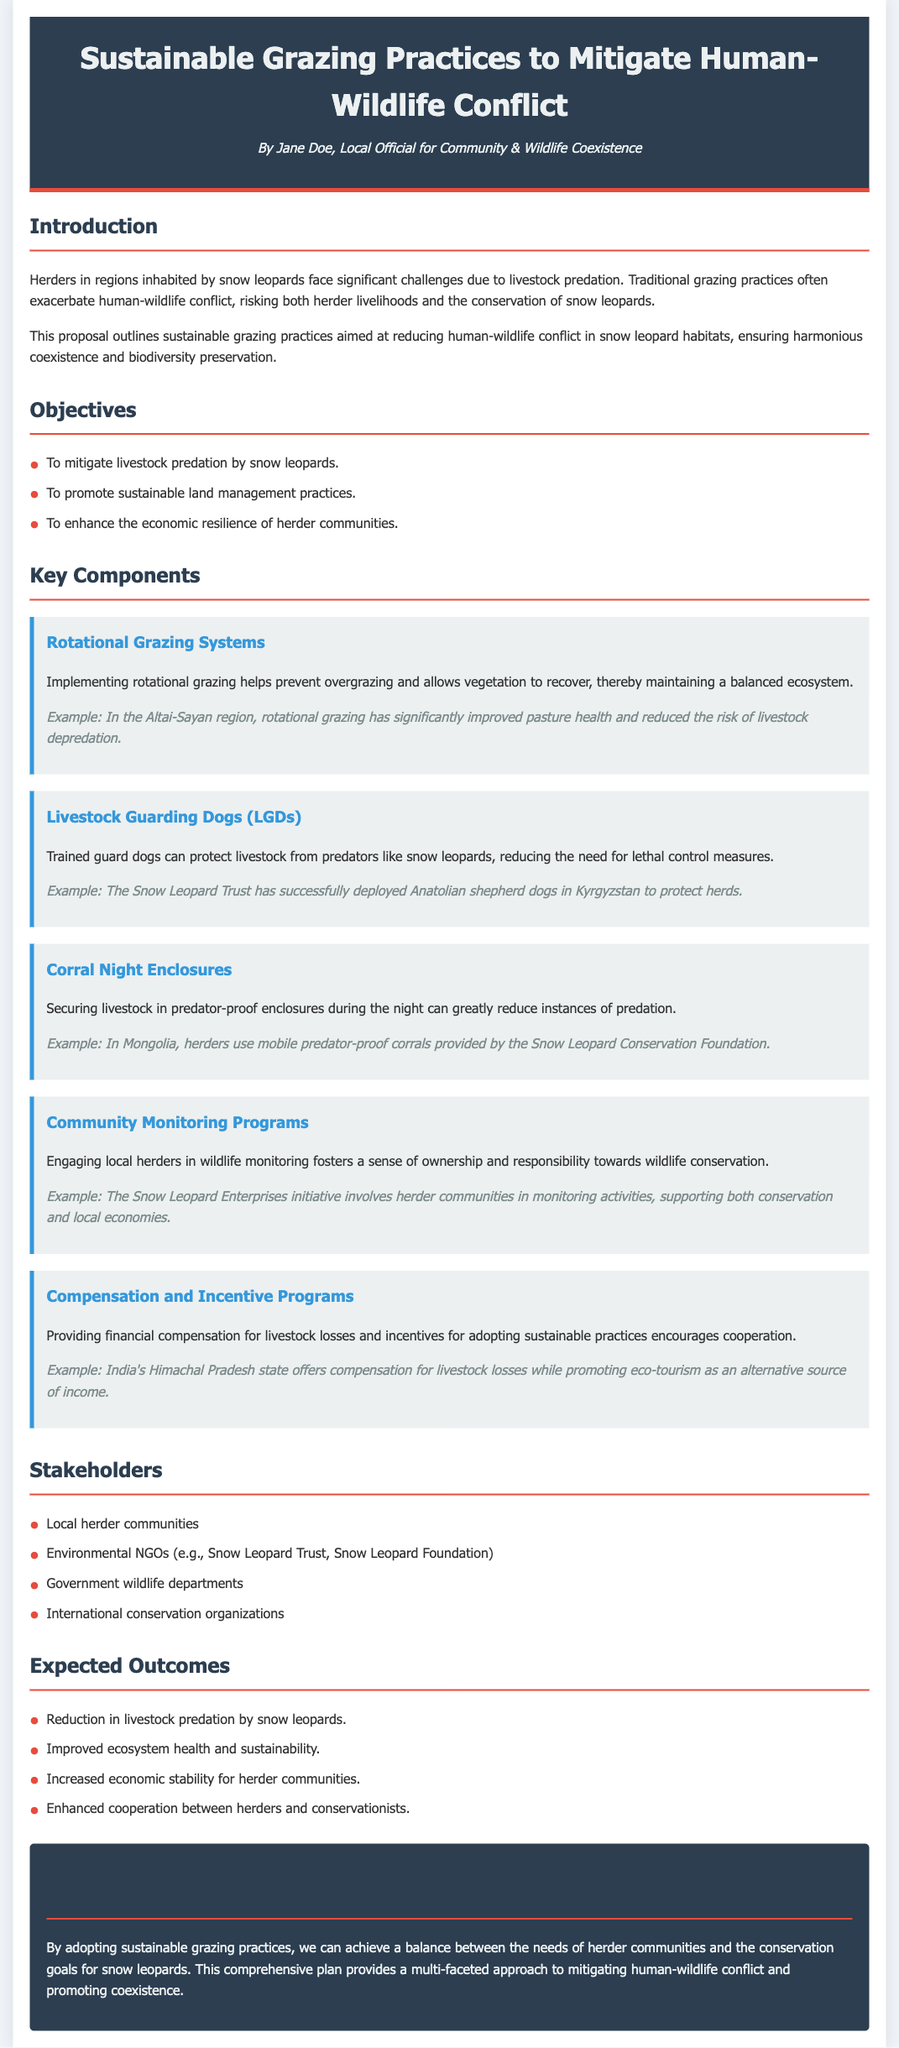What are the primary objectives of the proposal? The primary objectives are detailed in the 'Objectives' section, highlighting the goals to mitigate livestock predation, promote sustainable land management, and enhance economic resilience for herder communities.
Answer: Mitigate livestock predation, promote sustainable land management, enhance economic resilience Which sustainable grazing practice involves securing livestock at night? The practice of securing livestock at night is described in the 'Corral Night Enclosures' section, which emphasizes the importance of predator-proof enclosures.
Answer: Corral Night Enclosures What organization successfully deployed livestock guarding dogs in Kyrgyzstan? The deployment of livestock guarding dogs is attributed to the Snow Leopard Trust within the 'Livestock Guarding Dogs (LGDs)' section.
Answer: Snow Leopard Trust How many stakeholders are listed in the document? The 'Stakeholders' section lists four distinct groups involved in the initiative, which can be counted directly.
Answer: Four What is one expected outcome of implementing the proposed practices? Expected outcomes are detailed in the 'Expected Outcomes' section, indicating the goals anticipated from adopting the proposed practices.
Answer: Reduction in livestock predation by snow leopards What type of dogs are suggested for protecting livestock? In the 'Livestock Guarding Dogs (LGDs)' section, specific mention is made of trained guard dogs that help in predator protection.
Answer: Guard dogs Who authored the proposal? The author of the proposal is identified in the header section, providing the name of the individual responsible for the document.
Answer: Jane Doe 